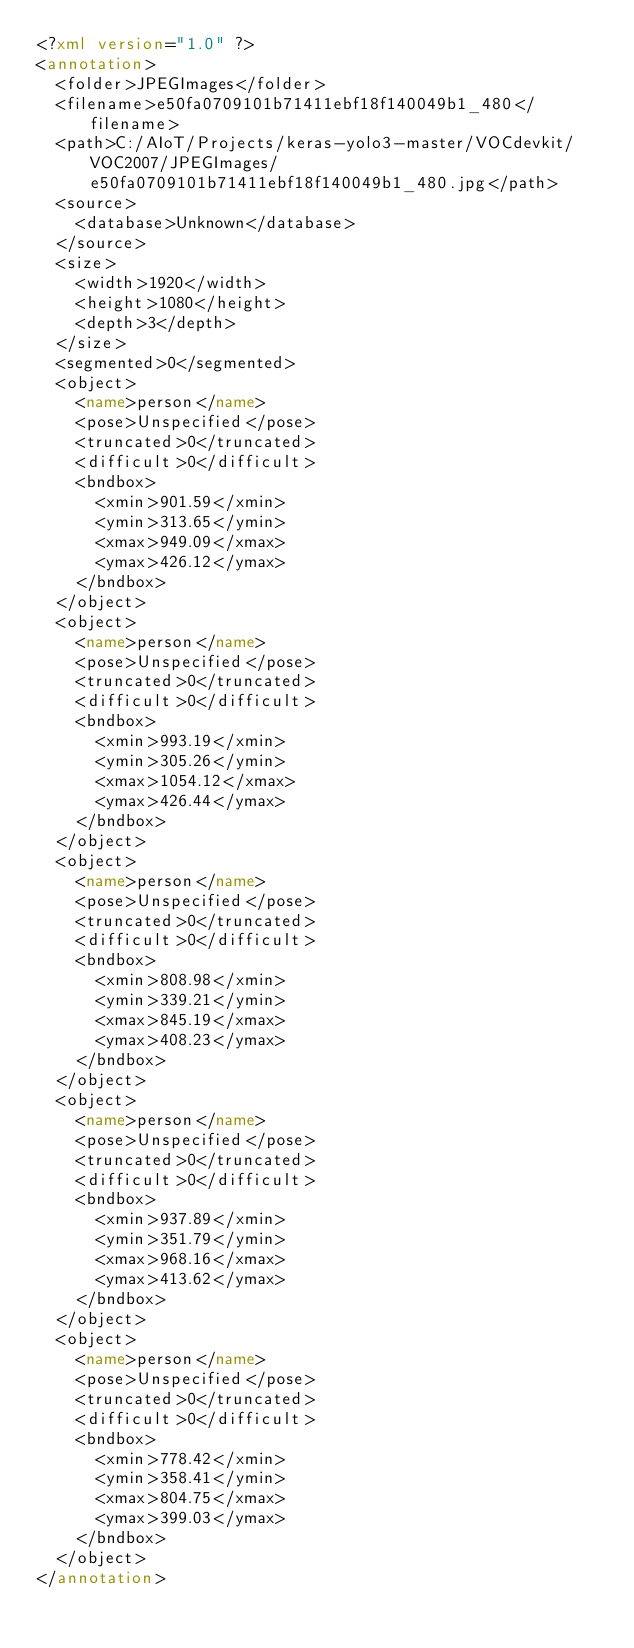Convert code to text. <code><loc_0><loc_0><loc_500><loc_500><_XML_><?xml version="1.0" ?>
<annotation>
	<folder>JPEGImages</folder>
	<filename>e50fa0709101b71411ebf18f140049b1_480</filename>
	<path>C:/AIoT/Projects/keras-yolo3-master/VOCdevkit/VOC2007/JPEGImages/e50fa0709101b71411ebf18f140049b1_480.jpg</path>
	<source>
		<database>Unknown</database>
	</source>
	<size>
		<width>1920</width>
		<height>1080</height>
		<depth>3</depth>
	</size>
	<segmented>0</segmented>
	<object>
		<name>person</name>
		<pose>Unspecified</pose>
		<truncated>0</truncated>
		<difficult>0</difficult>
		<bndbox>
			<xmin>901.59</xmin>
			<ymin>313.65</ymin>
			<xmax>949.09</xmax>
			<ymax>426.12</ymax>
		</bndbox>
	</object>
	<object>
		<name>person</name>
		<pose>Unspecified</pose>
		<truncated>0</truncated>
		<difficult>0</difficult>
		<bndbox>
			<xmin>993.19</xmin>
			<ymin>305.26</ymin>
			<xmax>1054.12</xmax>
			<ymax>426.44</ymax>
		</bndbox>
	</object>
	<object>
		<name>person</name>
		<pose>Unspecified</pose>
		<truncated>0</truncated>
		<difficult>0</difficult>
		<bndbox>
			<xmin>808.98</xmin>
			<ymin>339.21</ymin>
			<xmax>845.19</xmax>
			<ymax>408.23</ymax>
		</bndbox>
	</object>
	<object>
		<name>person</name>
		<pose>Unspecified</pose>
		<truncated>0</truncated>
		<difficult>0</difficult>
		<bndbox>
			<xmin>937.89</xmin>
			<ymin>351.79</ymin>
			<xmax>968.16</xmax>
			<ymax>413.62</ymax>
		</bndbox>
	</object>
	<object>
		<name>person</name>
		<pose>Unspecified</pose>
		<truncated>0</truncated>
		<difficult>0</difficult>
		<bndbox>
			<xmin>778.42</xmin>
			<ymin>358.41</ymin>
			<xmax>804.75</xmax>
			<ymax>399.03</ymax>
		</bndbox>
	</object>
</annotation>
</code> 